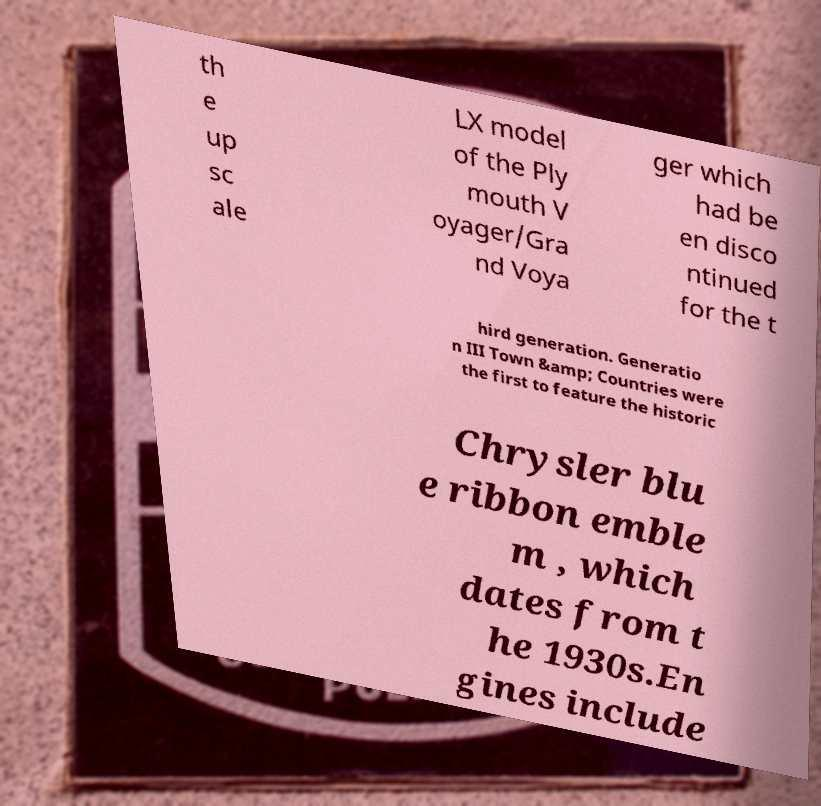Please read and relay the text visible in this image. What does it say? th e up sc ale LX model of the Ply mouth V oyager/Gra nd Voya ger which had be en disco ntinued for the t hird generation. Generatio n III Town &amp; Countries were the first to feature the historic Chrysler blu e ribbon emble m , which dates from t he 1930s.En gines include 